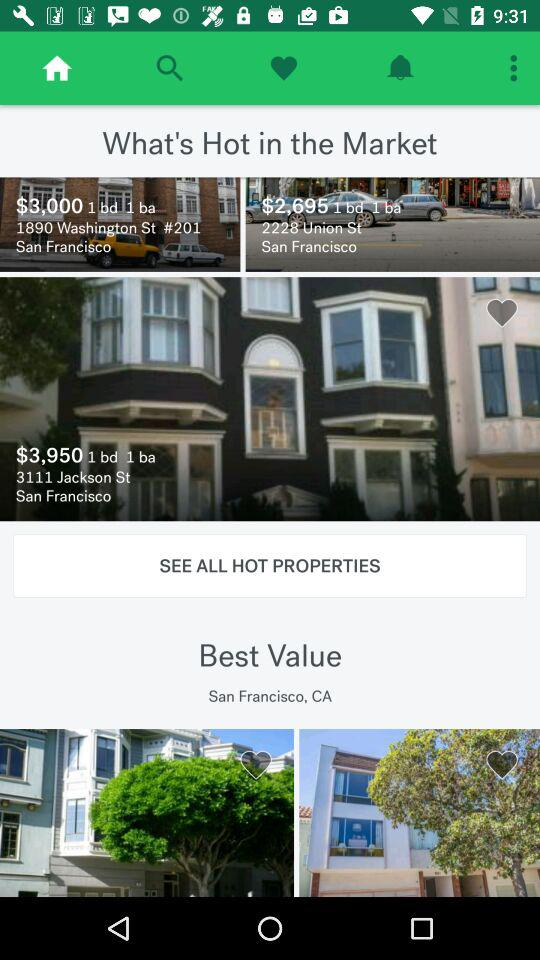What is the address of the property having price $3,950? The address is 3111 Jackson St, San Francisco. 